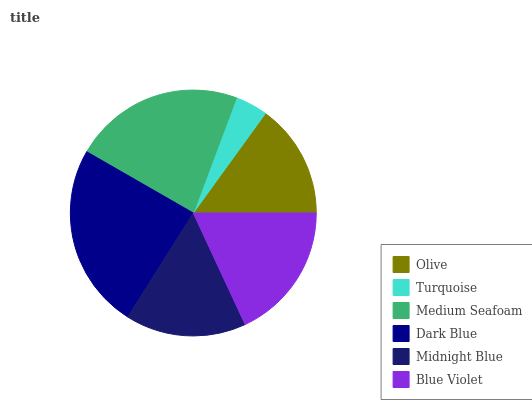Is Turquoise the minimum?
Answer yes or no. Yes. Is Dark Blue the maximum?
Answer yes or no. Yes. Is Medium Seafoam the minimum?
Answer yes or no. No. Is Medium Seafoam the maximum?
Answer yes or no. No. Is Medium Seafoam greater than Turquoise?
Answer yes or no. Yes. Is Turquoise less than Medium Seafoam?
Answer yes or no. Yes. Is Turquoise greater than Medium Seafoam?
Answer yes or no. No. Is Medium Seafoam less than Turquoise?
Answer yes or no. No. Is Blue Violet the high median?
Answer yes or no. Yes. Is Midnight Blue the low median?
Answer yes or no. Yes. Is Dark Blue the high median?
Answer yes or no. No. Is Turquoise the low median?
Answer yes or no. No. 